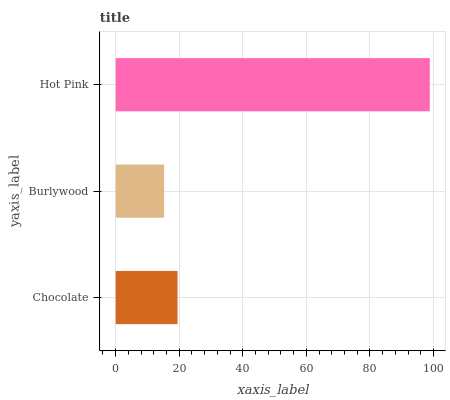Is Burlywood the minimum?
Answer yes or no. Yes. Is Hot Pink the maximum?
Answer yes or no. Yes. Is Hot Pink the minimum?
Answer yes or no. No. Is Burlywood the maximum?
Answer yes or no. No. Is Hot Pink greater than Burlywood?
Answer yes or no. Yes. Is Burlywood less than Hot Pink?
Answer yes or no. Yes. Is Burlywood greater than Hot Pink?
Answer yes or no. No. Is Hot Pink less than Burlywood?
Answer yes or no. No. Is Chocolate the high median?
Answer yes or no. Yes. Is Chocolate the low median?
Answer yes or no. Yes. Is Hot Pink the high median?
Answer yes or no. No. Is Hot Pink the low median?
Answer yes or no. No. 